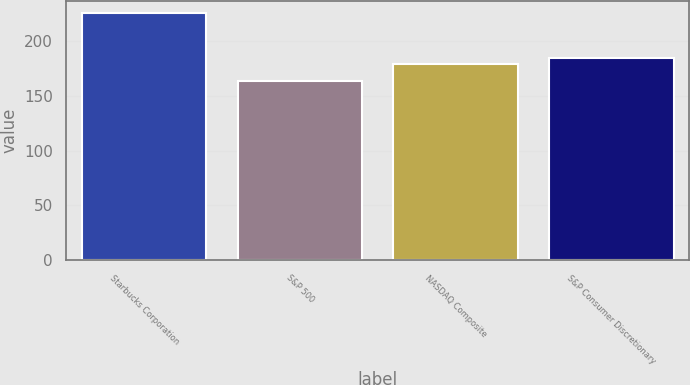Convert chart. <chart><loc_0><loc_0><loc_500><loc_500><bar_chart><fcel>Starbucks Corporation<fcel>S&P 500<fcel>NASDAQ Composite<fcel>S&P Consumer Discretionary<nl><fcel>225.7<fcel>163.93<fcel>178.82<fcel>185<nl></chart> 